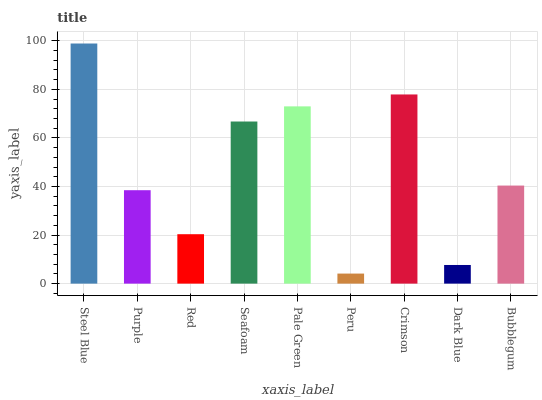Is Peru the minimum?
Answer yes or no. Yes. Is Steel Blue the maximum?
Answer yes or no. Yes. Is Purple the minimum?
Answer yes or no. No. Is Purple the maximum?
Answer yes or no. No. Is Steel Blue greater than Purple?
Answer yes or no. Yes. Is Purple less than Steel Blue?
Answer yes or no. Yes. Is Purple greater than Steel Blue?
Answer yes or no. No. Is Steel Blue less than Purple?
Answer yes or no. No. Is Bubblegum the high median?
Answer yes or no. Yes. Is Bubblegum the low median?
Answer yes or no. Yes. Is Steel Blue the high median?
Answer yes or no. No. Is Dark Blue the low median?
Answer yes or no. No. 